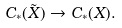Convert formula to latex. <formula><loc_0><loc_0><loc_500><loc_500>C _ { * } ( \tilde { X } ) \to C _ { * } ( X ) .</formula> 